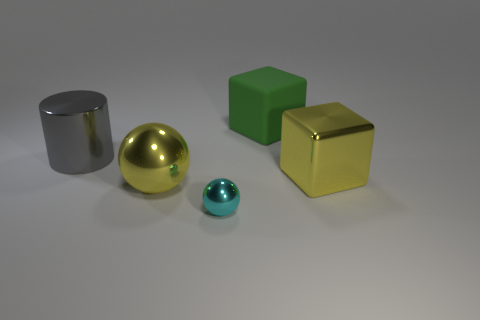Add 3 large metallic spheres. How many objects exist? 8 Subtract all yellow spheres. How many spheres are left? 1 Subtract all cylinders. How many objects are left? 4 Subtract 1 cylinders. How many cylinders are left? 0 Subtract all blue spheres. How many purple blocks are left? 0 Add 1 tiny cyan objects. How many tiny cyan objects exist? 2 Subtract 1 cyan balls. How many objects are left? 4 Subtract all blue balls. Subtract all blue blocks. How many balls are left? 2 Subtract all metallic blocks. Subtract all balls. How many objects are left? 2 Add 4 yellow shiny cubes. How many yellow shiny cubes are left? 5 